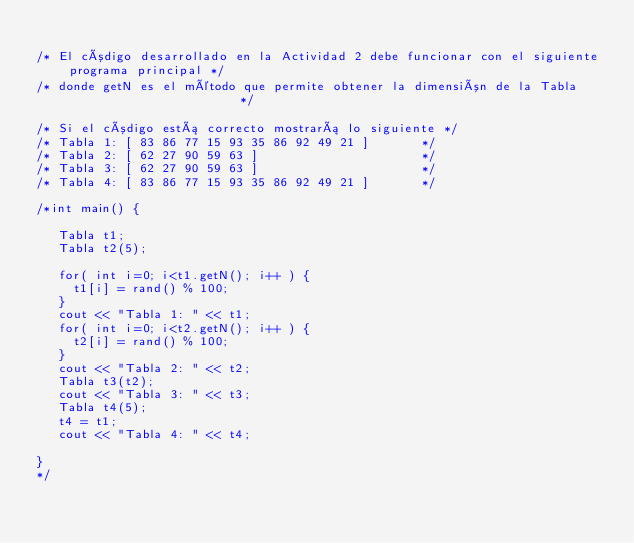Convert code to text. <code><loc_0><loc_0><loc_500><loc_500><_C++_>
/* El código desarrollado en la Actividad 2 debe funcionar con el siguiente programa principal */
/* donde getN es el método que permite obtener la dimensión de la Tabla                        */

/* Si el código está correcto mostrará lo siguiente */
/* Tabla 1: [ 83 86 77 15 93 35 86 92 49 21 ]       */
/* Tabla 2: [ 62 27 90 59 63 ]                      */
/* Tabla 3: [ 62 27 90 59 63 ]                      */
/* Tabla 4: [ 83 86 77 15 93 35 86 92 49 21 ]       */

/*int main() {

   Tabla t1; 
   Tabla t2(5);

   for( int i=0; i<t1.getN(); i++ ) { 
     t1[i] = rand() % 100;
   }   
   cout << "Tabla 1: " << t1; 
   for( int i=0; i<t2.getN(); i++ ) { 
     t2[i] = rand() % 100;
   }   
   cout << "Tabla 2: " << t2; 
   Tabla t3(t2);
   cout << "Tabla 3: " << t3; 
   Tabla t4(5);
   t4 = t1; 
   cout << "Tabla 4: " << t4; 

}
*/
</code> 